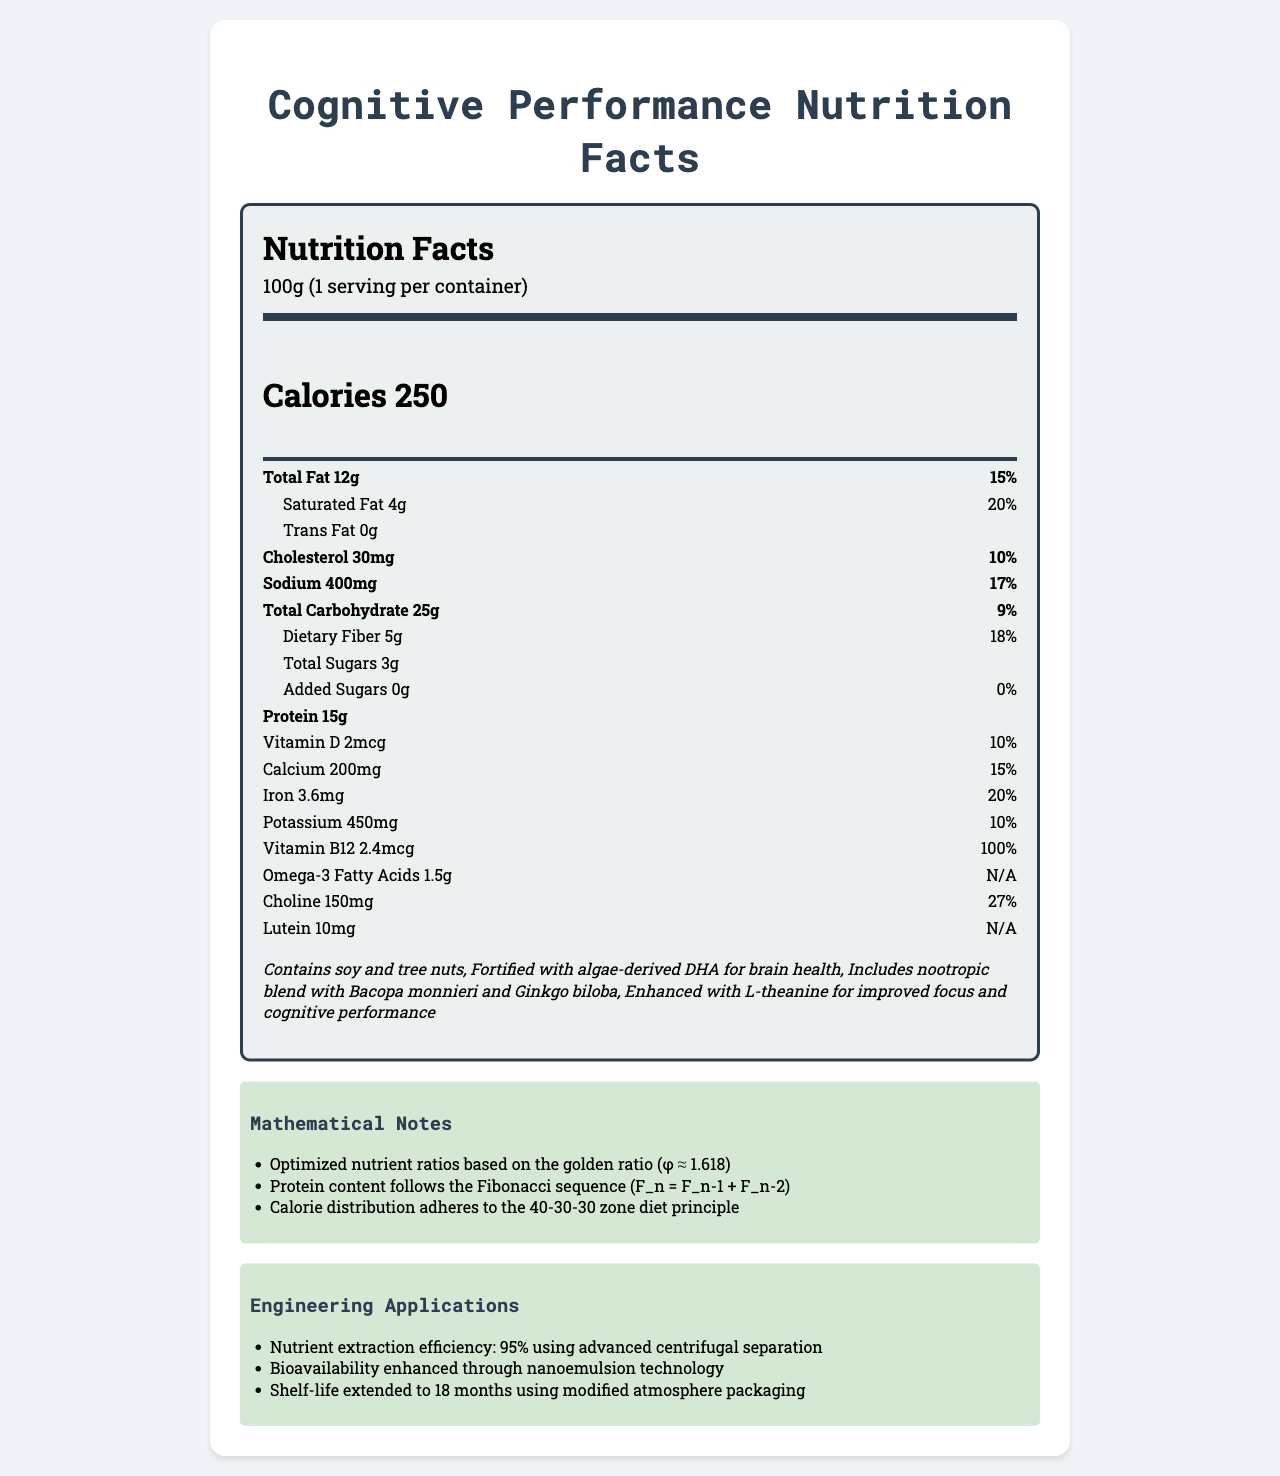what is the serving size? The serving size is directly mentioned as "100g" in the document.
Answer: 100g how many calories are in one serving? The document states that each serving contains 250 calories.
Answer: 250 how much total fat does the product contain, and what is the percent daily value? The document lists the total fat as 12g and the percent daily value as 15%.
Answer: 12g, 15% how much protein is in the product? The document states there are 15g of protein in the product.
Answer: 15g what are the two unique components listed under "additional info" for cognitive performance? These components are listed as part of the additional info in the document.
Answer: Algae-derived DHA and nootropic blend with Bacopa monnieri and Ginkgo biloba which nutrient has the highest percent daily value? A. Vitamin D B. Calcium C. Iron D. Vitamin B12 Vitamin B12 has a percent daily value of 100%, which is higher than the others listed.
Answer: D. Vitamin B12 what nutrient amount follows the Fibonacci sequence mentioned in the mathematical notes? A. Amino Acids B. Protein C. Carbohydrates D. Vitamins The mathematical notes specify that the protein content follows the Fibonacci sequence.
Answer: B. Protein has this product been enhanced using any specific technology? Yes/No The document mentions bioavailability enhancement through nanoemulsion technology and modified atmosphere packaging for extending shelf-life.
Answer: Yes describe the additional methods used for improving cognitive performance in this product. This information is provided in the additional info section of the document.
Answer: The product is fortified with algae-derived DHA for brain health, includes a nootropic blend with Bacopa monnieri and Ginkgo biloba, and is enhanced with L-theanine for improved focus and cognitive performance. what is the total carbohydrate content, and how much of it is dietary fiber? The document specifies a total carbohydrate content of 25g, with 5g as dietary fiber.
Answer: 25g total, 5g dietary fiber are there any added sugars in this product? The document explicitly states that there are 0g of added sugars.
Answer: No how is the nutrient extraction efficiency achieved in this product? The document lists nutrient extraction efficiency and the method used under engineering applications.
Answer: Through advanced centrifugal separation with 95% efficiency which of the following is NOT mentioned in the mathematical notes? I. Golden ratio II. Pythagorean theorem III. Fibonacci sequence The Pythagorean theorem is not mentioned; the golden ratio and Fibonacci sequence are mentioned.
Answer: II. Pythagorean theorem does this product contain any allergens? The additional info mentions that the product contains soy and tree nuts.
Answer: Yes summarize the main idea of the document. The document summarizes the comprehensive nutritional content, including specific enhancements for cognitive health and technological advancements used in product development.
Answer: The document provides a detailed Nutrition Facts Label for a product designed to improve cognitive performance, highlighting essential nutrients, mathematical optimizations, engineering applications, and additional components for brain health. can you determine the specific source of omega-3 fatty acids from the document? The document mentions the presence of omega-3 fatty acids but does not specify their source.
Answer: Not enough information 